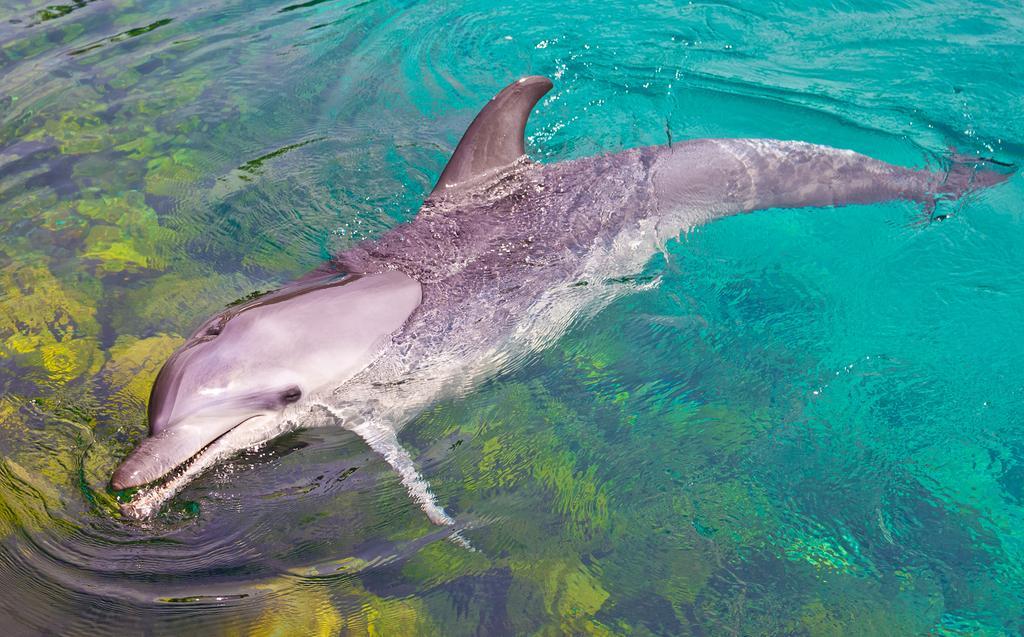Could you give a brief overview of what you see in this image? In the foreground of this image, there is a dolphin in the water. 